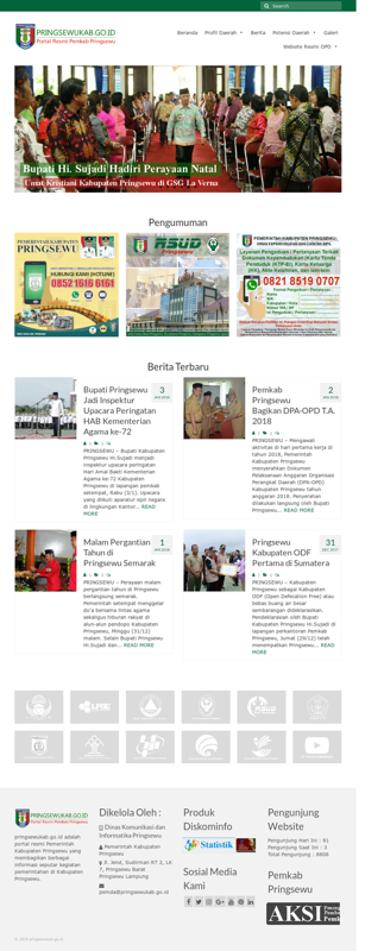Are there any social media links provided on the website? Yes, the website includes a section for social media links, encouraging visitors to engage with the entity's activities on popular social platforms. This shows their effort to maintain transparency and connectivity with the public. 